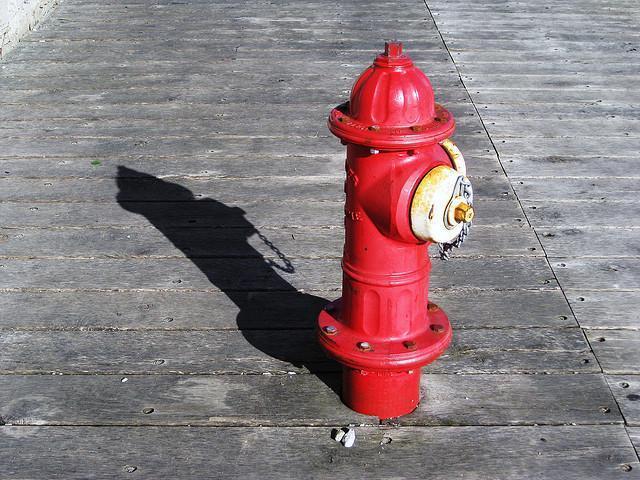How many people are standing up?
Give a very brief answer. 0. 